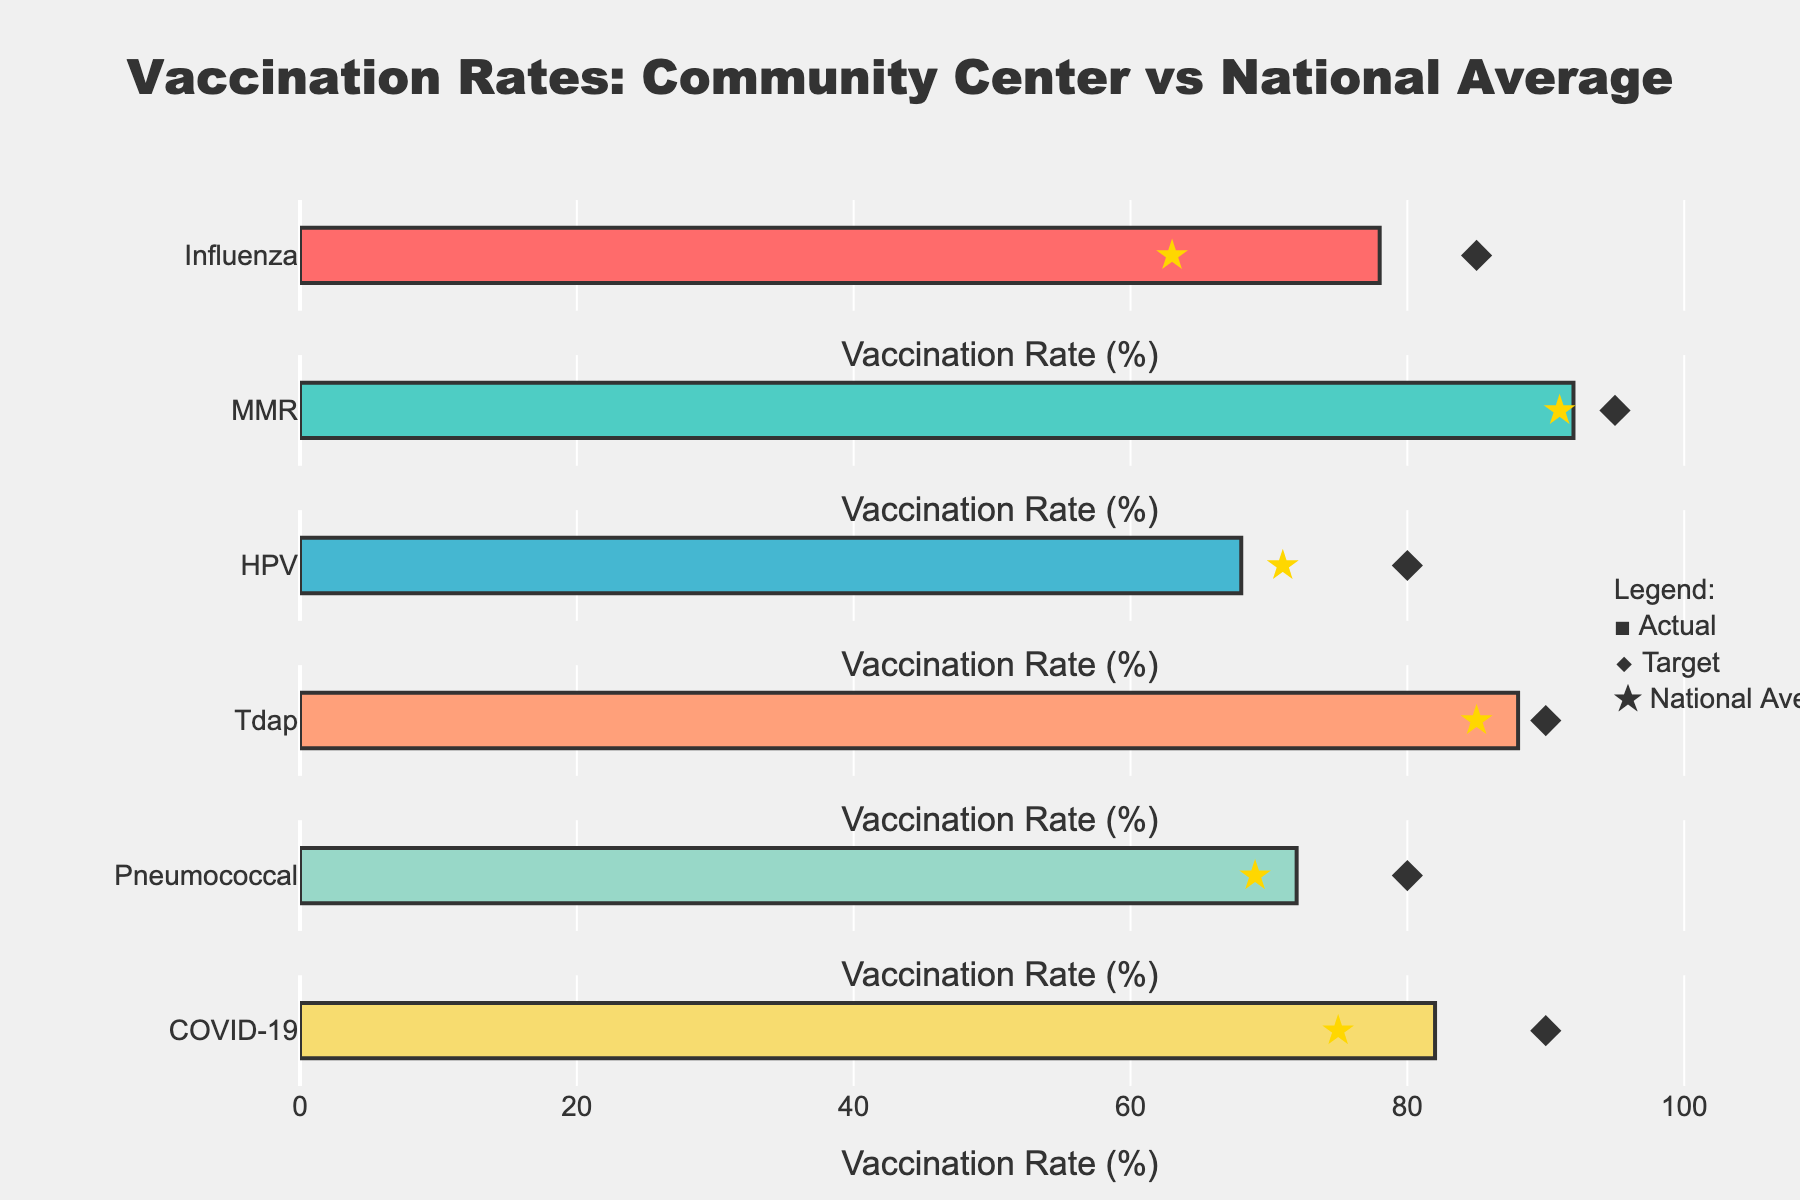What is the title of the chart? The title is usually displayed prominently at the top of the chart. In this case, the title is "Vaccination Rates: Community Center vs National Average".
Answer: Vaccination Rates: Community Center vs National Average How many different categories of vaccinations are shown in the chart? There are six bars, each representing different vaccination categories, and each bar corresponds to a different type of vaccination.
Answer: Six Which vaccination category has the highest 'Actual' rate? The bar with the highest 'Actual' rate will be the longest. In this case, "MMR" has the highest 'Actual' rate at 92%.
Answer: MMR How does the 'Actual' rate for the COVID-19 vaccine compare to its 'Target'? For comparison, look at the length of the bar (Actual) and the diamond marker (Target) for the COVID-19 row. The 'Actual' is 82%, while the 'Target' is 90%.
Answer: 82% vs 90% Which vaccination category has the largest gap between its 'Actual' rate and its 'Target'? To find the largest gap, subtract the 'Actual' rate from the 'Target' rate for each category and identify the largest difference. For Influenza, it's (85 - 78 = 7); MMR (95 - 92 = 3); HPV (80 - 68 = 12); Tdap (90 - 88 = 2); Pneumococcal (80 - 72 = 8); COVID-19 (90 - 82 = 8). The largest gap is in HPV with 12%.
Answer: HPV In which categories does the 'Actual' rate exceed the 'National Average'? Compare the bar lengths (Actual) with the star markers (National Average) for each category. The categories where 'Actual' is greater than 'National Average' are Influenza (78% vs 63%), MMR (92% vs 91%), Tdap (88% vs 85%), Pneumococcal (72% vs 69%), and COVID-19 (82% vs 75%).
Answer: Influenza, MMR, Tdap, Pneumococcal, COVID-19 What is the 'Actual' rate for HPV, and how does it compare to the 'National Average'? Check the bar length for HPV to find the 'Actual' rate, which is 68%. The star marker shows the National Average is 71%. So, the 'Actual' rate is lower than the 'National Average'.
Answer: 68% is less than 71% Which vaccination category has the smallest difference between 'Actual' and 'National Average'? Calculate the absolute differences between 'Actual' and 'National Average' for each category: Influenza (78 - 63 = 15), MMR (92 - 91 = 1), HPV (68 - 71 = 3), Tdap (88 - 85 = 3), Pneumococcal (72 - 69 = 3), COVID-19 (82 - 75 = 7). The smallest difference is in MMR with a difference of 1.
Answer: MMR For which category is the 'Actual' rate closest to meeting its 'Target'? Subtract 'Actual' from 'Target' and find the smallest difference: Influenza (85 - 78 = 7), MMR (95 - 92 = 3), HPV (80 - 68 = 12), Tdap (90 - 88 = 2), Pneumococcal (80 - 72 = 8), COVID-19 (90 - 82 = 8). Tdap has the smallest difference of 2.
Answer: Tdap 